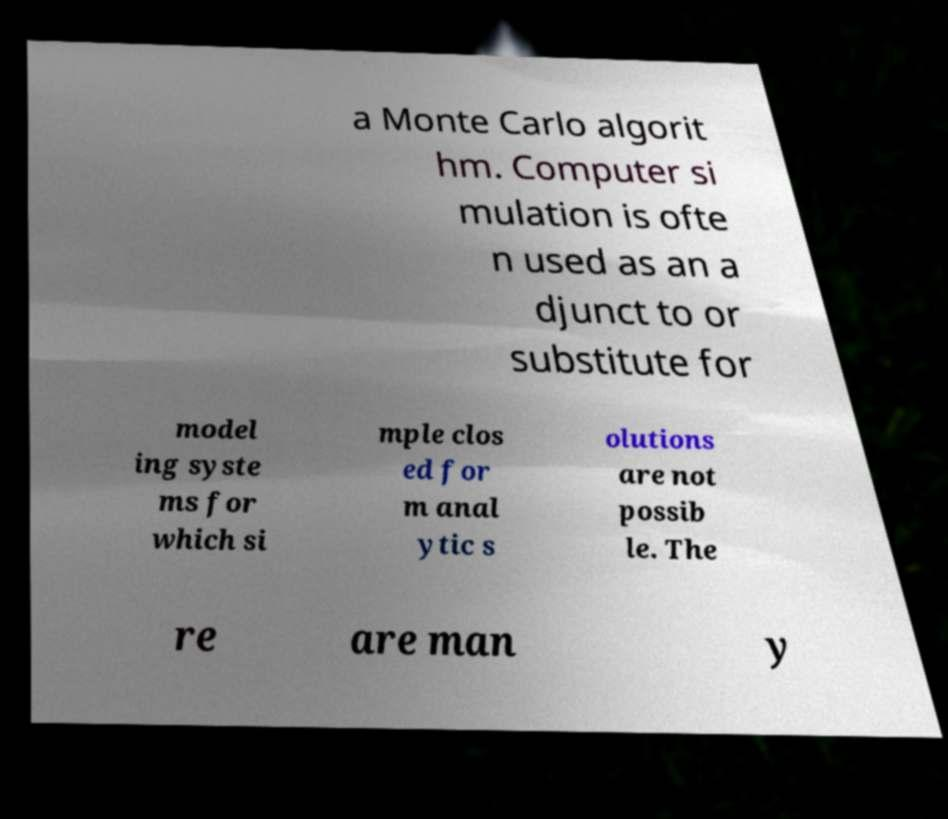Can you read and provide the text displayed in the image?This photo seems to have some interesting text. Can you extract and type it out for me? a Monte Carlo algorit hm. Computer si mulation is ofte n used as an a djunct to or substitute for model ing syste ms for which si mple clos ed for m anal ytic s olutions are not possib le. The re are man y 